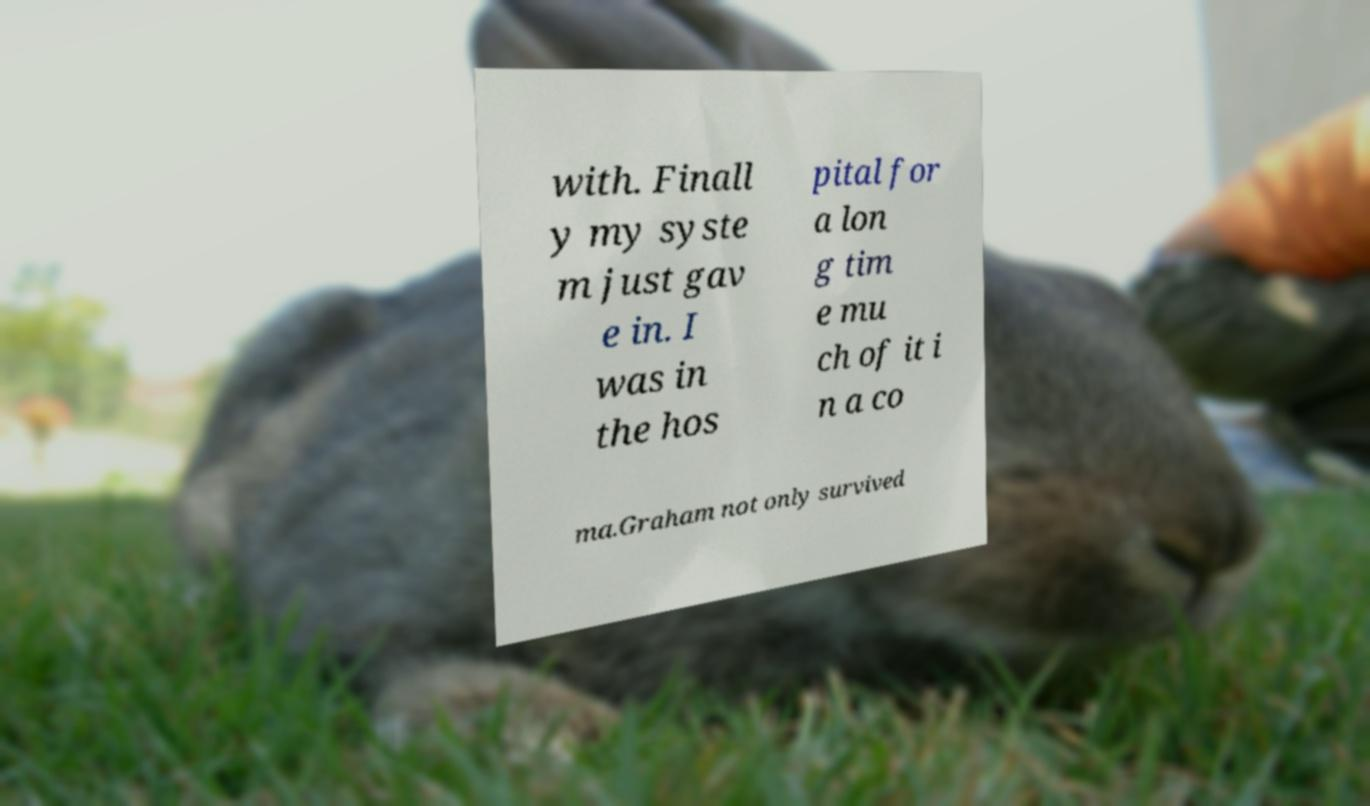Can you accurately transcribe the text from the provided image for me? with. Finall y my syste m just gav e in. I was in the hos pital for a lon g tim e mu ch of it i n a co ma.Graham not only survived 